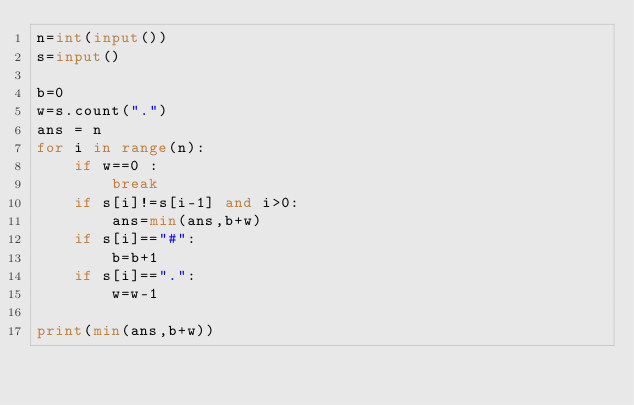Convert code to text. <code><loc_0><loc_0><loc_500><loc_500><_Python_>n=int(input())
s=input()

b=0
w=s.count(".")
ans = n
for i in range(n):
    if w==0 :
        break
    if s[i]!=s[i-1] and i>0:
        ans=min(ans,b+w)
    if s[i]=="#":
        b=b+1
    if s[i]==".":
        w=w-1
    
print(min(ans,b+w))</code> 